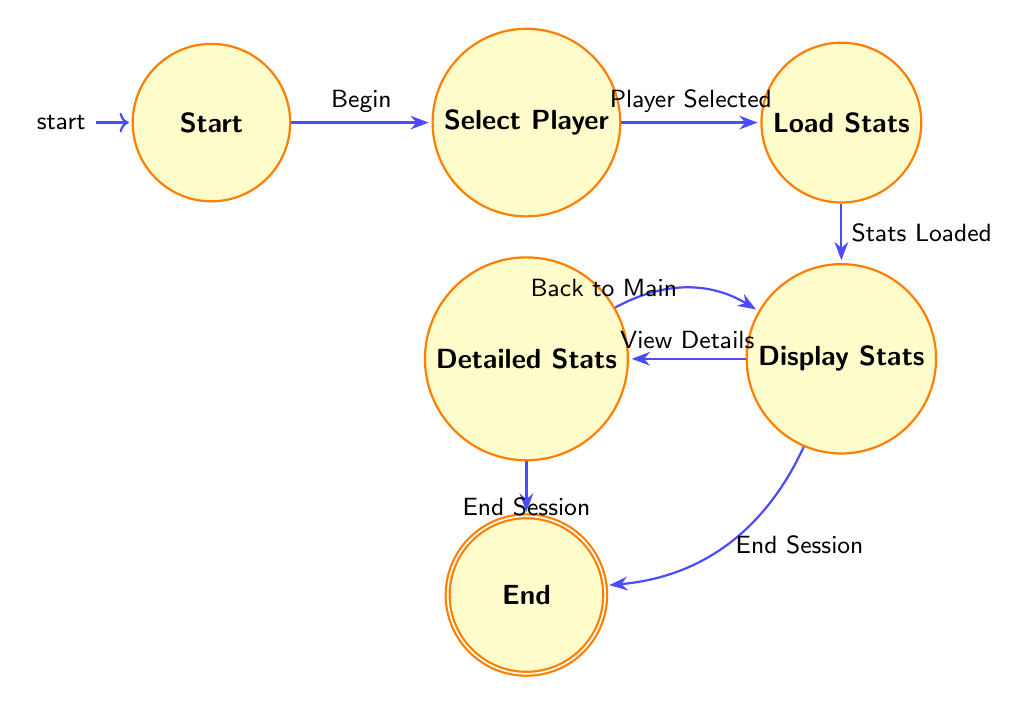What is the initial state of the diagram? The diagram starts in the "Start" state, which is the designated initial node of the finite state machine.
Answer: Start How many states are there in total? Counting the nodes presented in the diagram, there are five distinct states: Start, Select Player, Load Stats, Display Stats, Detailed Stats, and End, which sums up to six states.
Answer: Six What action transitions from 'Select Player' to 'Load Stats'? The transition action that occurs from the 'Select Player' state to the 'Load Stats' state is labeled "Player Selected."
Answer: Player Selected From 'Display Player Stats', what are the two possible actions? The two possible actions that can be taken from the 'Display Player Stats' state are "View Detailed Stats" and "End Session."
Answer: View Detailed Stats, End Session What happens if you choose to "End Session" from 'Display Player Stats'? If you choose to "End Session" from 'Display Player Stats', the next state achieved is 'End', which signifies the conclusion of the tracking session.
Answer: End If you are in the 'Detailed Stats', which action leads back to 'Display Player Stats'? The action that leads back to 'Display Player Stats' from the 'Detailed Stats' state is "Back to Main Stats".
Answer: Back to Main Stats What is the last state in the sequence? The last state in the sequence is labeled as 'End', indicating the termination of the player performance tracking session.
Answer: End What is the description of the 'Load Player Stats' state? The 'Load Player Stats' state is described as loading the statistics for the selected player, reflecting its function within the process.
Answer: Load statistics for the selected player What does the transition from 'Detailed Stats' to 'End' signify? The transition from 'Detailed Stats' to 'End' signifies the conclusion of the player performance tracking when the user chooses "End Session" while viewing detailed stats.
Answer: Concludes session 